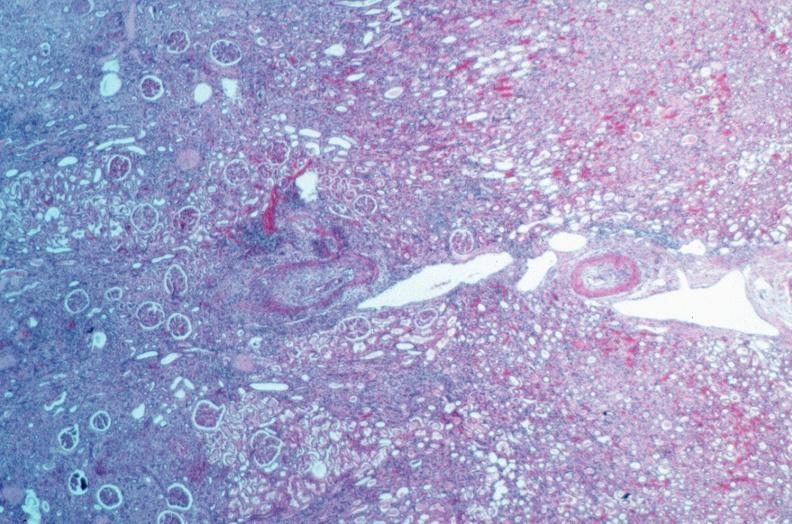s cardiovascular present?
Answer the question using a single word or phrase. Yes 